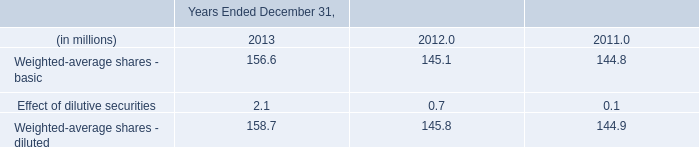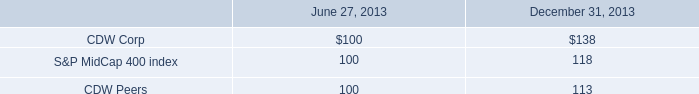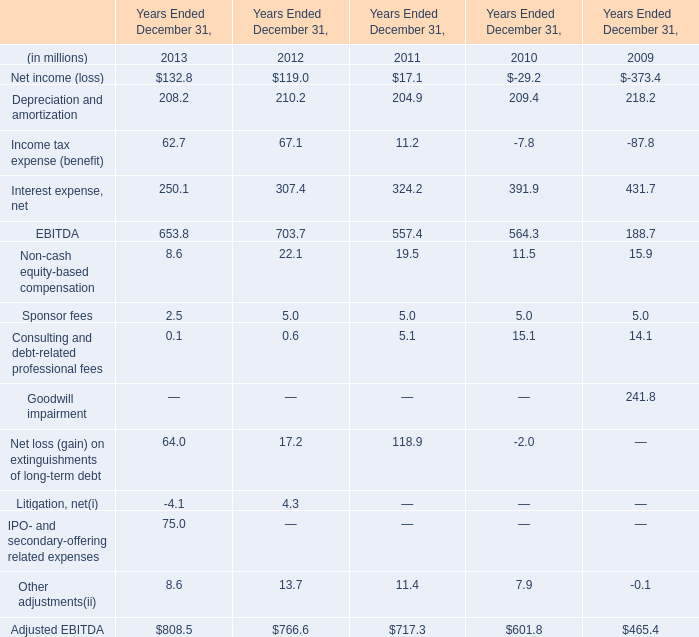how many ipo shares did the company sell in july 2013? 
Computations: (23250000 + 3487500)
Answer: 26737500.0. 